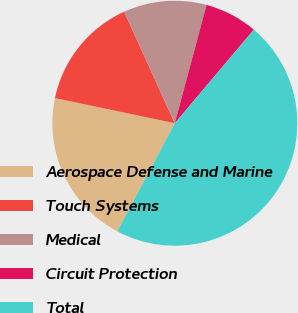<chart> <loc_0><loc_0><loc_500><loc_500><pie_chart><fcel>Aerospace Defense and Marine<fcel>Touch Systems<fcel>Medical<fcel>Circuit Protection<fcel>Total<nl><fcel>20.51%<fcel>14.92%<fcel>10.96%<fcel>6.99%<fcel>46.62%<nl></chart> 